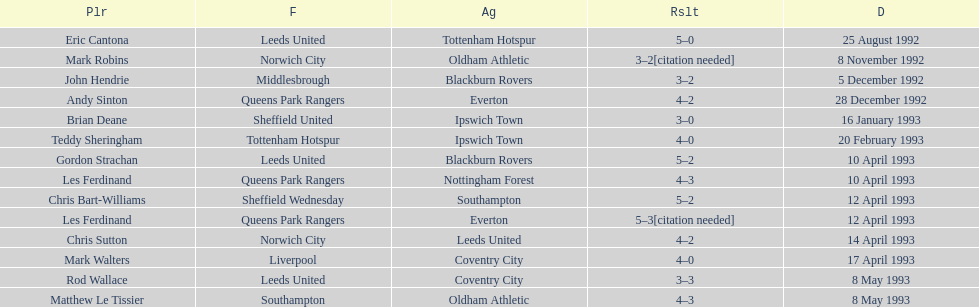How many players were for leeds united? 3. 